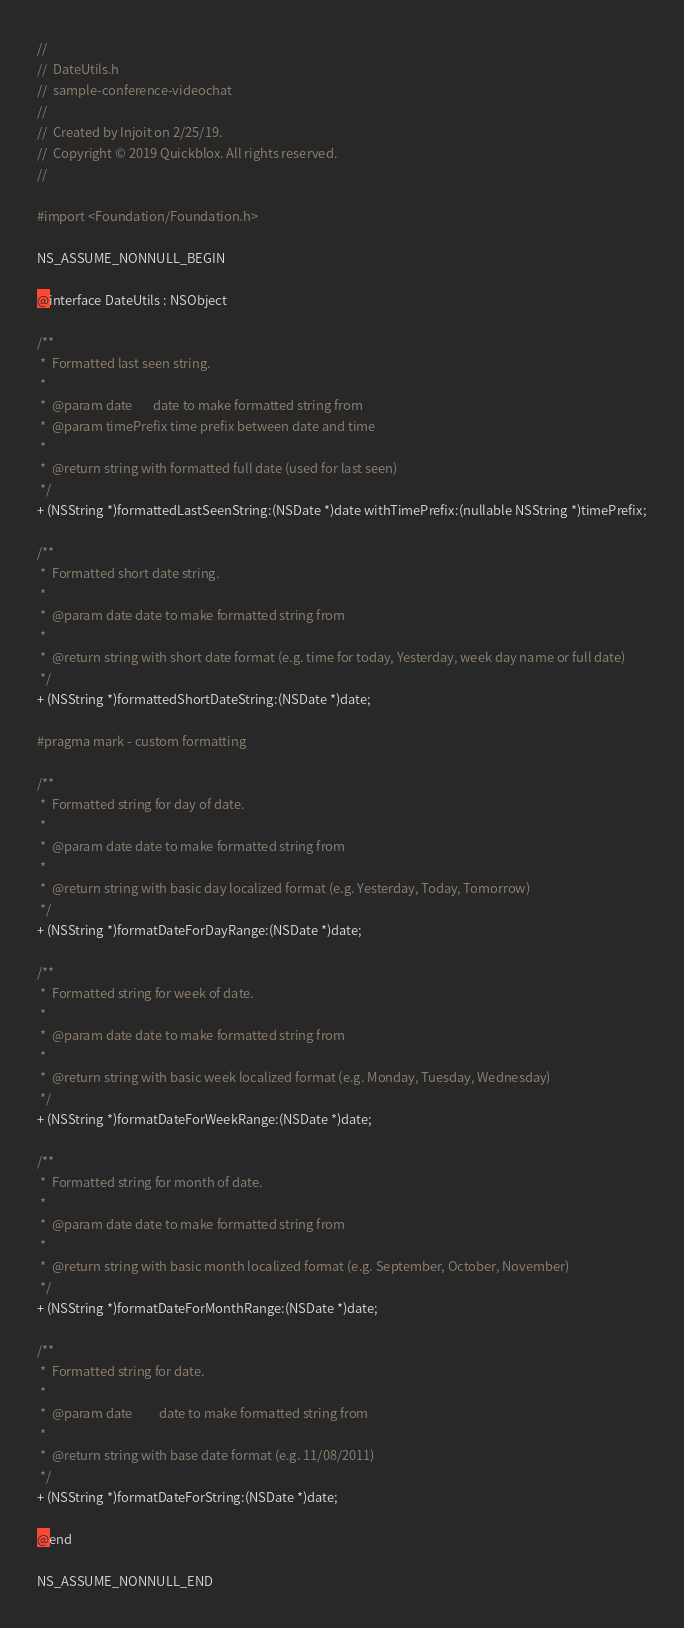Convert code to text. <code><loc_0><loc_0><loc_500><loc_500><_C_>//
//  DateUtils.h
//  sample-conference-videochat
//
//  Created by Injoit on 2/25/19.
//  Copyright © 2019 Quickblox. All rights reserved.
//

#import <Foundation/Foundation.h>

NS_ASSUME_NONNULL_BEGIN

@interface DateUtils : NSObject

/**
 *  Formatted last seen string.
 *
 *  @param date       date to make formatted string from
 *  @param timePrefix time prefix between date and time
 *
 *  @return string with formatted full date (used for last seen)
 */
+ (NSString *)formattedLastSeenString:(NSDate *)date withTimePrefix:(nullable NSString *)timePrefix;

/**
 *  Formatted short date string.
 *
 *  @param date date to make formatted string from
 *
 *  @return string with short date format (e.g. time for today, Yesterday, week day name or full date)
 */
+ (NSString *)formattedShortDateString:(NSDate *)date;

#pragma mark - custom formatting

/**
 *  Formatted string for day of date.
 *
 *  @param date date to make formatted string from
 *
 *  @return string with basic day localized format (e.g. Yesterday, Today, Tomorrow)
 */
+ (NSString *)formatDateForDayRange:(NSDate *)date;

/**
 *  Formatted string for week of date.
 *
 *  @param date date to make formatted string from
 *
 *  @return string with basic week localized format (e.g. Monday, Tuesday, Wednesday)
 */
+ (NSString *)formatDateForWeekRange:(NSDate *)date;

/**
 *  Formatted string for month of date.
 *
 *  @param date date to make formatted string from
 *
 *  @return string with basic month localized format (e.g. September, October, November)
 */
+ (NSString *)formatDateForMonthRange:(NSDate *)date;

/**
 *  Formatted string for date.
 *
 *  @param date         date to make formatted string from
 *
 *  @return string with base date format (e.g. 11/08/2011)
 */
+ (NSString *)formatDateForString:(NSDate *)date;

@end

NS_ASSUME_NONNULL_END
</code> 